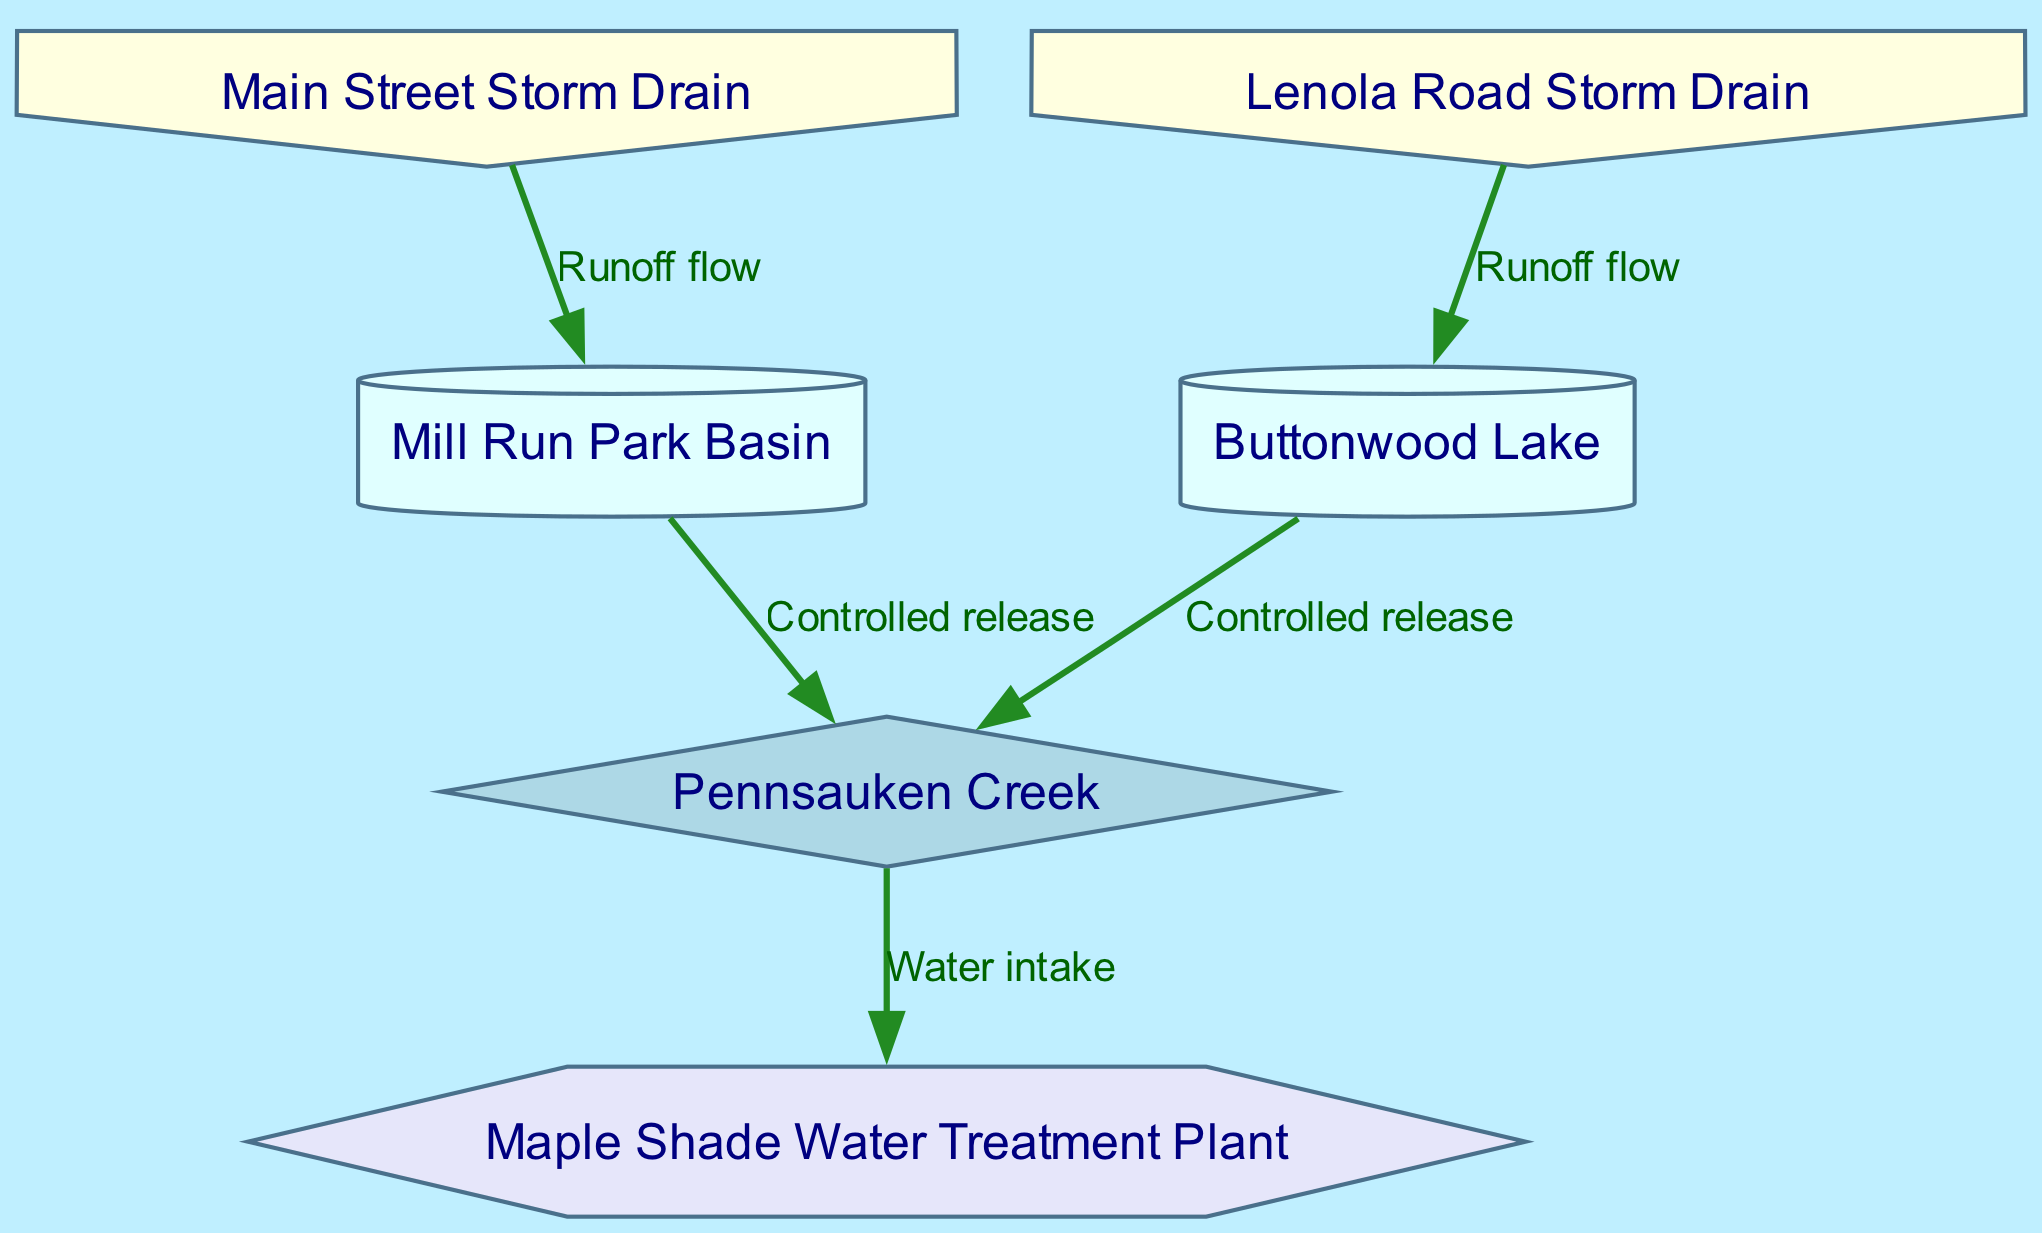What are the labels of the retention basins? The diagram includes two retention basins, Mill Run Park Basin and Buttonwood Lake. These are labeled as such on the diagram.
Answer: Mill Run Park Basin, Buttonwood Lake How many storm drains are present in the diagram? By counting the nodes labeled as storm drains in the diagram, there are two: Main Street Storm Drain and Lenola Road Storm Drain.
Answer: 2 Which facility receives water from the main creek? The diagram shows a directed edge from the main creek to the Maple Shade Water Treatment Plant, indicating that this facility receives the water.
Answer: Maple Shade Water Treatment Plant What type of flow is indicated between the storm drains and retention basins? The edges from the storm drains to the retention basins are labeled as "Runoff flow," indicating the type of relationship between these nodes.
Answer: Runoff flow Which retention basin discharges water to the main creek first in the flow sequence? The edges from both retention basins to the main creek have the same label "Controlled release," indicating that they might discharge simultaneously. However, visually, it can be interpreted that Mill Run Park Basin is the first in the flow order due to its position.
Answer: Mill Run Park Basin What is the shape of the node representing the main creek? The main creek is represented with a diamond shape in the diagram, which is standard for indicating an important water feature like a creek.
Answer: Diamond Which edge represents the flow from Buttonwood Lake? The edge from Lenola Road Storm Drain to retention basin 2 (Buttonwood Lake) is labeled "Runoff flow," indicating the direction and type of this flow.
Answer: Runoff flow How does water flow from the retention basins to the main creek? Water flows from both retention basins to the main creek through edges labeled as "Controlled release," showing a directed flow from the basins to the creek.
Answer: Controlled release How many edges are present in the diagram? The diagram illustrates four connections (edges) between nodes, representing the interactions and flow types throughout the stormwater management system.
Answer: 5 